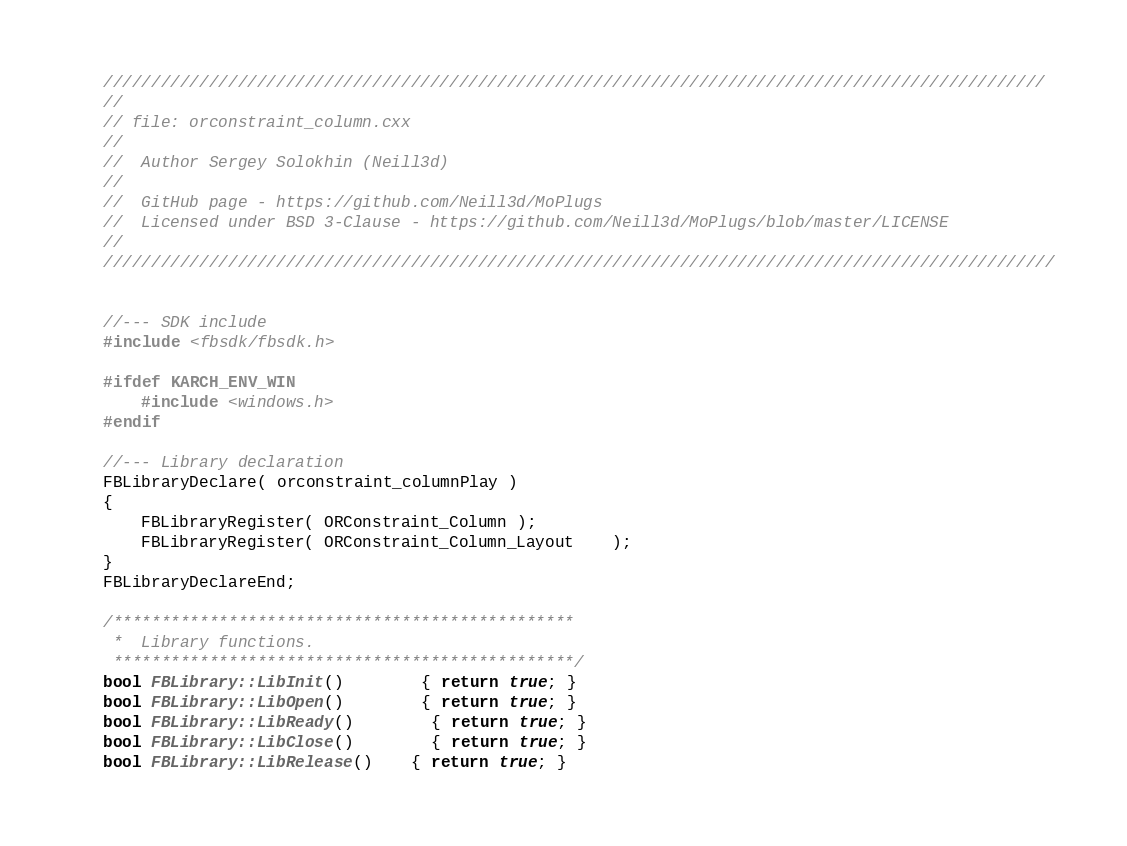<code> <loc_0><loc_0><loc_500><loc_500><_C++_>
//////////////////////////////////////////////////////////////////////////////////////////////////
//
// file: orconstraint_column.cxx
//
//	Author Sergey Solokhin (Neill3d)
//
//	GitHub page - https://github.com/Neill3d/MoPlugs
//	Licensed under BSD 3-Clause - https://github.com/Neill3d/MoPlugs/blob/master/LICENSE
//
///////////////////////////////////////////////////////////////////////////////////////////////////


//--- SDK include
#include <fbsdk/fbsdk.h>

#ifdef KARCH_ENV_WIN
	#include <windows.h>
#endif

//--- Library declaration
FBLibraryDeclare( orconstraint_columnPlay )
{
	FBLibraryRegister( ORConstraint_Column );
	FBLibraryRegister( ORConstraint_Column_Layout	);
}
FBLibraryDeclareEnd;

/************************************************
 *	Library functions.
 ************************************************/
bool FBLibrary::LibInit()		{ return true; }
bool FBLibrary::LibOpen()		{ return true; }
bool FBLibrary::LibReady()		{ return true; }
bool FBLibrary::LibClose()		{ return true; }
bool FBLibrary::LibRelease()	{ return true; }
</code> 